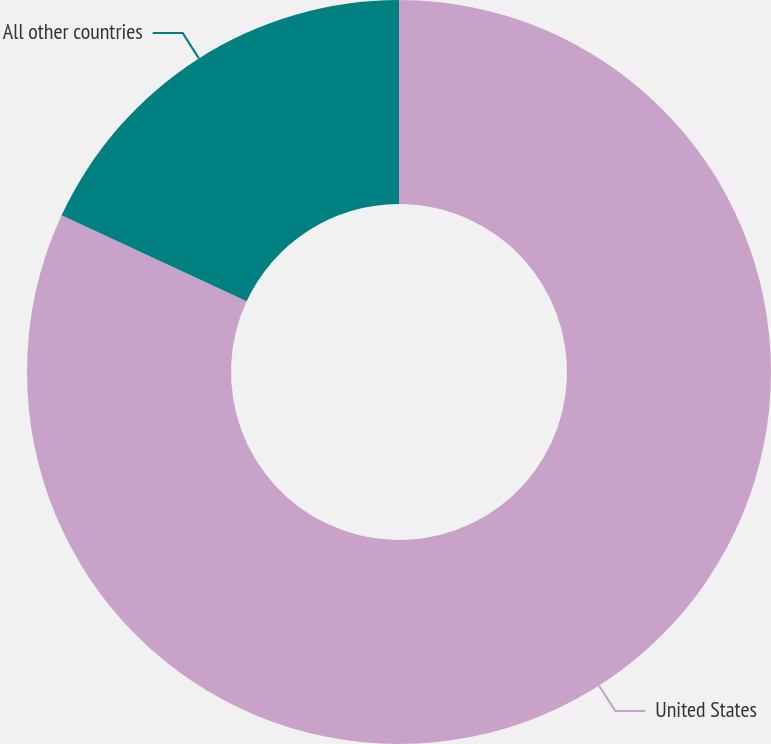Convert chart to OTSL. <chart><loc_0><loc_0><loc_500><loc_500><pie_chart><fcel>United States<fcel>All other countries<nl><fcel>81.92%<fcel>18.08%<nl></chart> 